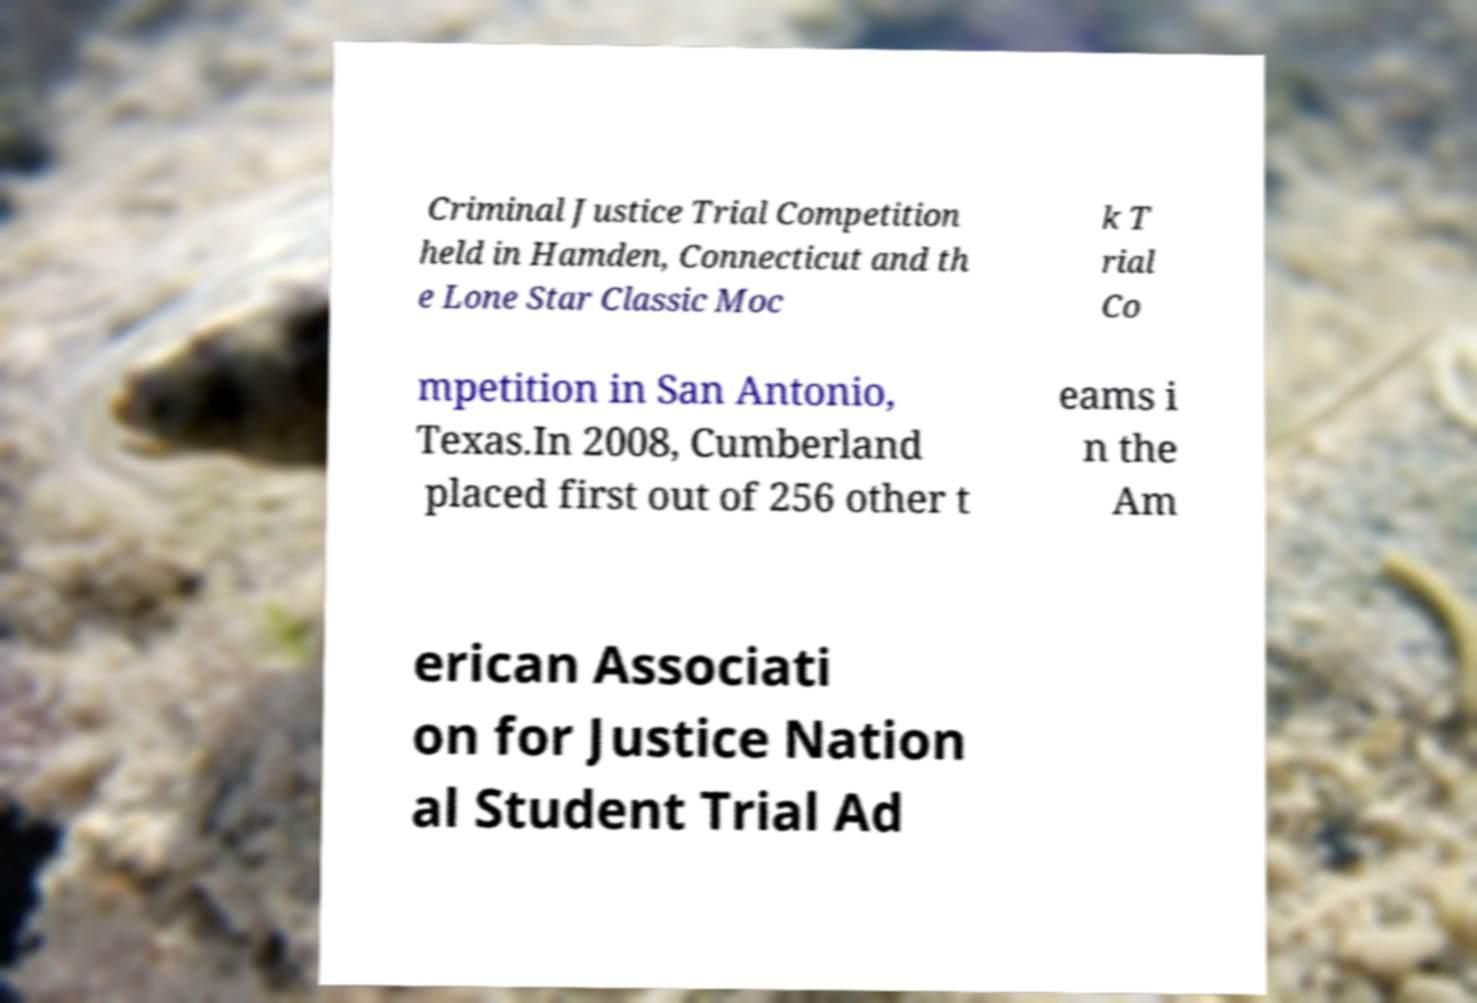Can you accurately transcribe the text from the provided image for me? Criminal Justice Trial Competition held in Hamden, Connecticut and th e Lone Star Classic Moc k T rial Co mpetition in San Antonio, Texas.In 2008, Cumberland placed first out of 256 other t eams i n the Am erican Associati on for Justice Nation al Student Trial Ad 